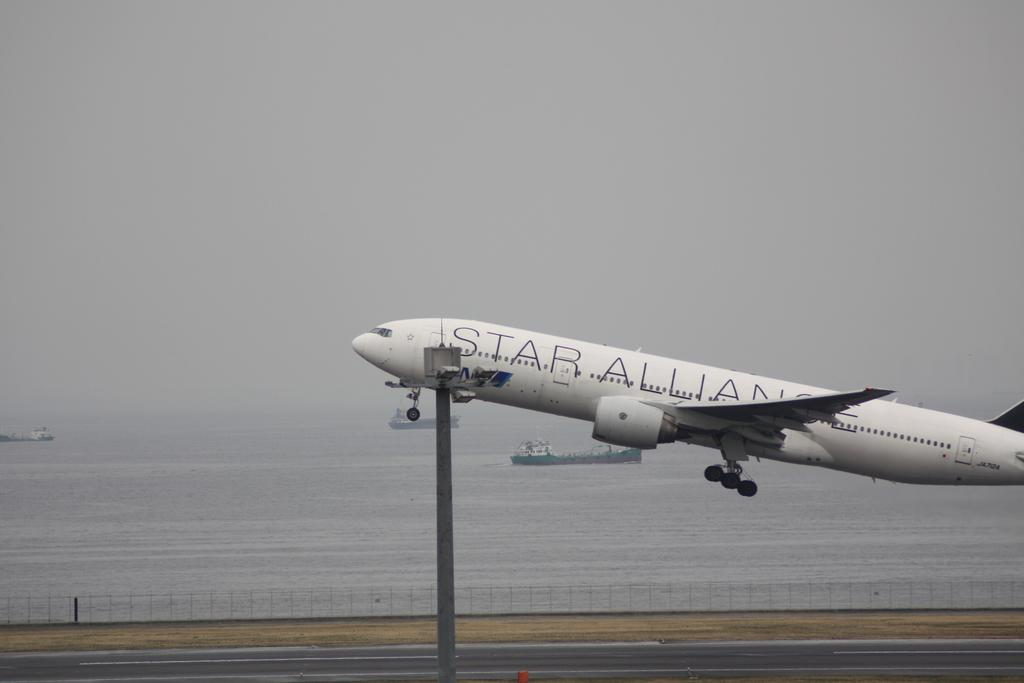Provide a one-sentence caption for the provided image. A white airplane with the words Star Alliance on the side taking off. 